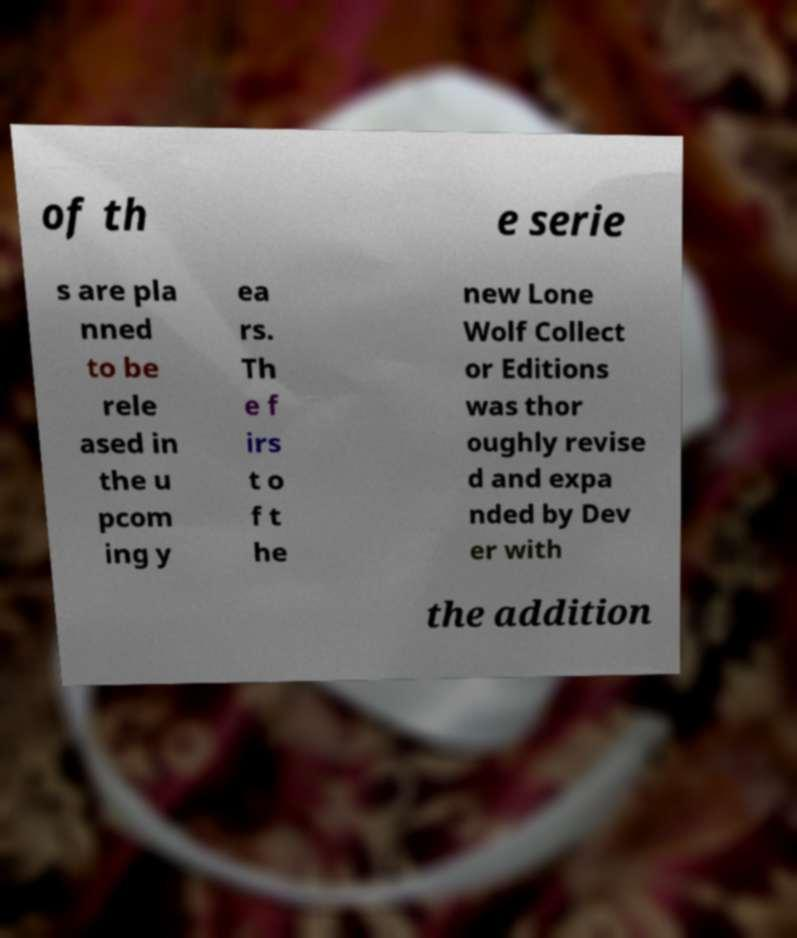There's text embedded in this image that I need extracted. Can you transcribe it verbatim? of th e serie s are pla nned to be rele ased in the u pcom ing y ea rs. Th e f irs t o f t he new Lone Wolf Collect or Editions was thor oughly revise d and expa nded by Dev er with the addition 